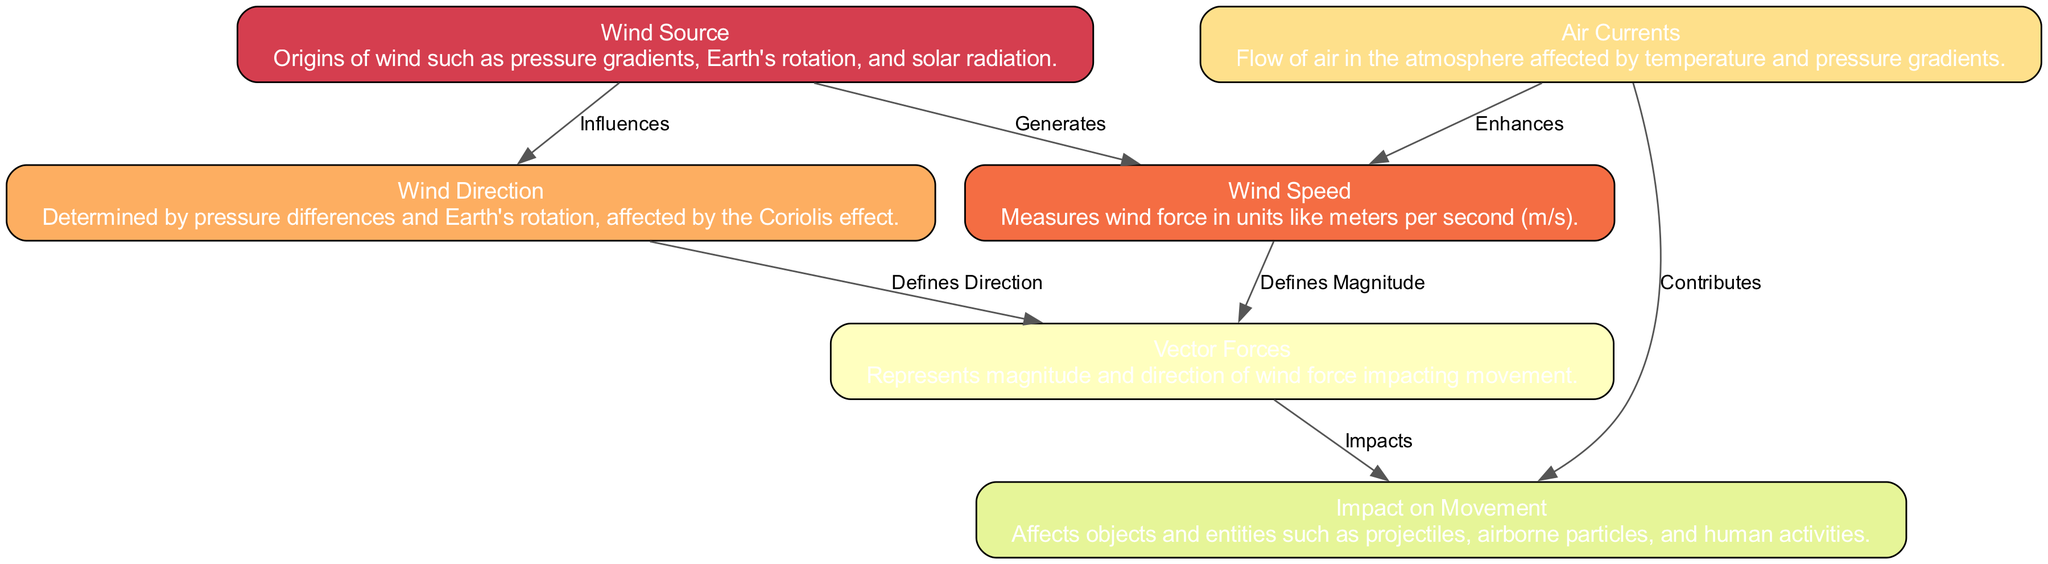What is the origin of wind according to the diagram? The diagram identifies the "Wind Source" as the origin of wind, which includes factors such as pressure gradients, Earth's rotation, and solar radiation. These elements generate wind in the atmosphere.
Answer: Wind Source How many nodes are present in the diagram? By counting the individual elements labeled as nodes in the diagram, we find there are a total of six distinct nodes, each representing different aspects of wind physics.
Answer: 6 Which node describes the flow of air in the atmosphere? The node labeled "Air Currents" specifically describes the flow of air in the atmosphere and indicates that this flow is influenced by temperature and pressure gradients.
Answer: Air Currents What relationship exists between Wind Speed and Vector Forces? The diagram shows that "Wind Speed" defines the magnitude of "Vector Forces," indicating that the speed of the wind directly influences how strong the force vectors are that act on moving objects.
Answer: Defines Magnitude What influences Wind Direction according to the diagram? The "Wind Direction" is influenced by pressure differences as well as the Coriolis effect, which is a key factor in determining the direction of wind flow across the Earth's surface.
Answer: Pressure differences and Coriolis effect How do Air Currents contribute to movements according to the diagram? Air Currents contribute to the movement of various entities by affecting the dynamics of the environment, as indicated in the relationship that demonstrates how they influence the impact on movement.
Answer: Contributes What is the connection between Wind Source and Wind Direction? The "Wind Source" influences "Wind Direction" by affecting the pressure differences and Earth's rotation, which ultimately determine how and where the wind travels.
Answer: Influences What are the two primary factors mentioned that affect the movement as per the diagram? The diagram indicates that "Vector Forces" and "Air Currents" are the two primary factors that impact movements, showing their interconnected roles in how wind affects various moving objects.
Answer: Vector Forces and Air Currents 